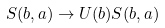Convert formula to latex. <formula><loc_0><loc_0><loc_500><loc_500>S ( b , a ) \rightarrow U ( b ) S ( b , a )</formula> 